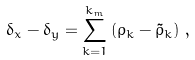Convert formula to latex. <formula><loc_0><loc_0><loc_500><loc_500>\delta _ { x } - \delta _ { y } = \sum _ { k = 1 } ^ { k _ { m } } \left ( \rho _ { k } - \tilde { \rho } _ { k } \right ) \, ,</formula> 